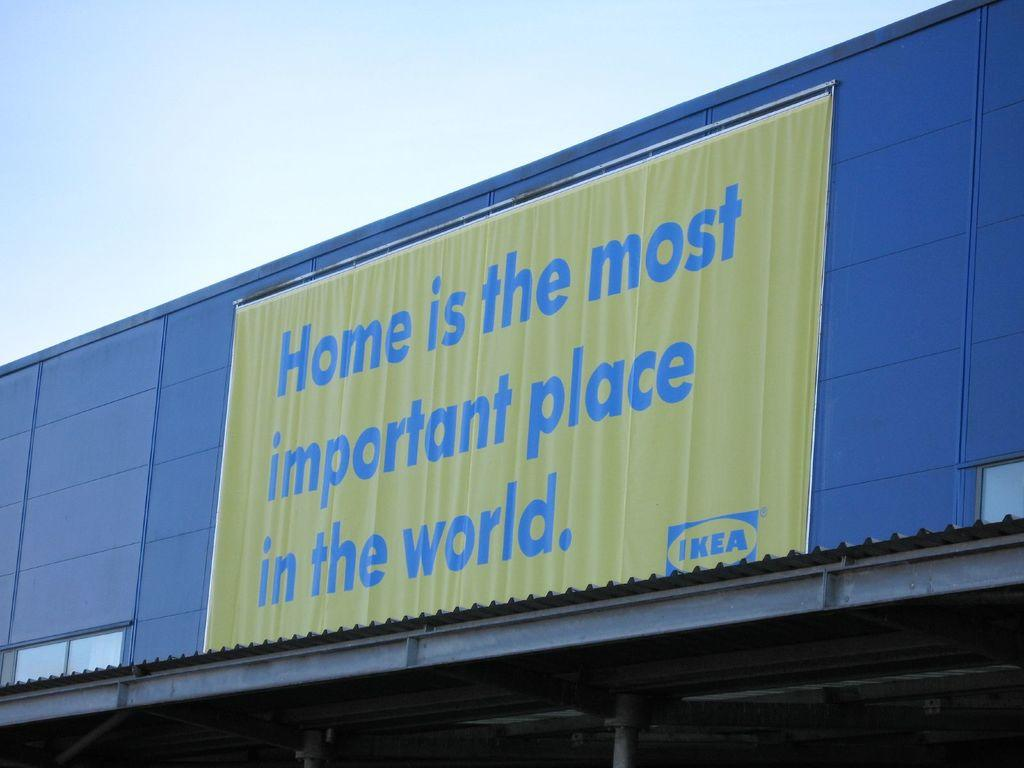<image>
Summarize the visual content of the image. An Ikea sign says that Home is the most important place in the world. 